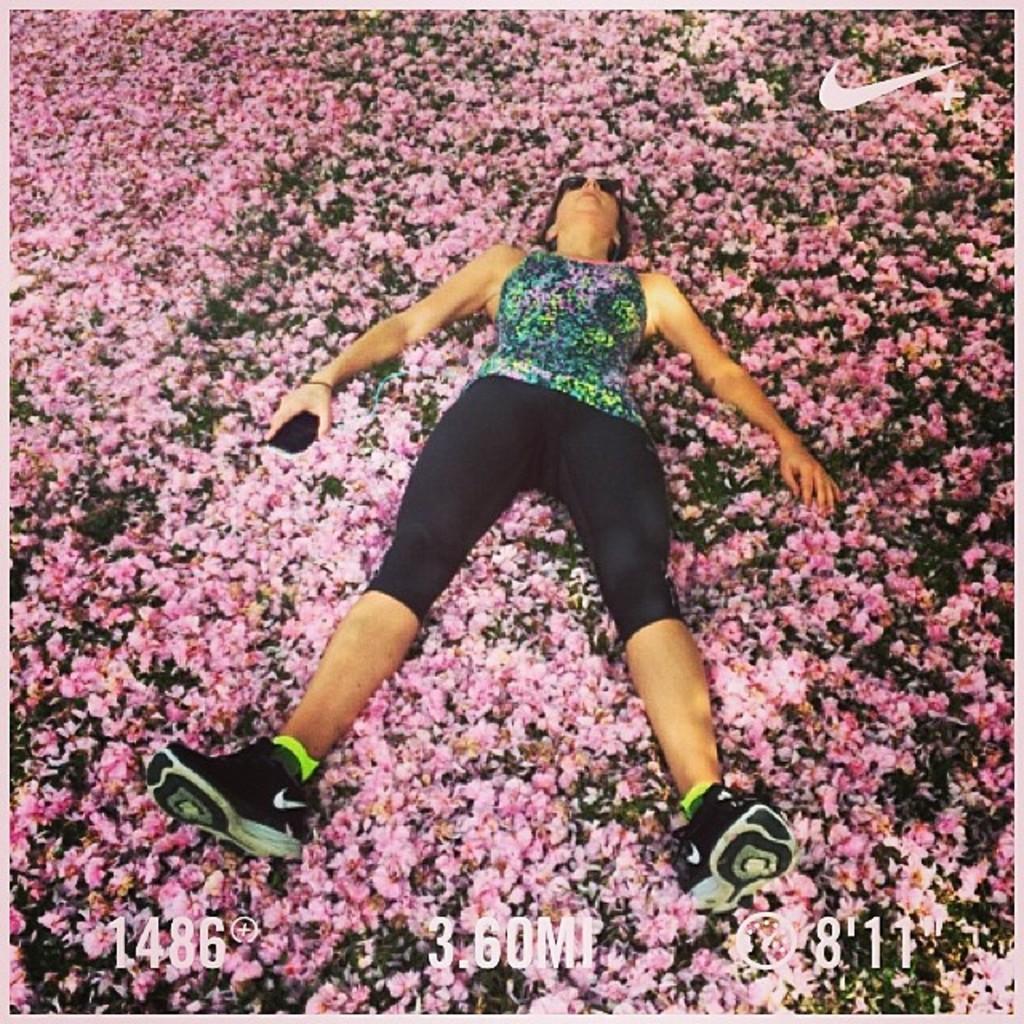Describe this image in one or two sentences. In this image we can see a lady person wearing multi color top, black color bottom, shoes holding some object in her hands sleeping on flowers which are on ground. 